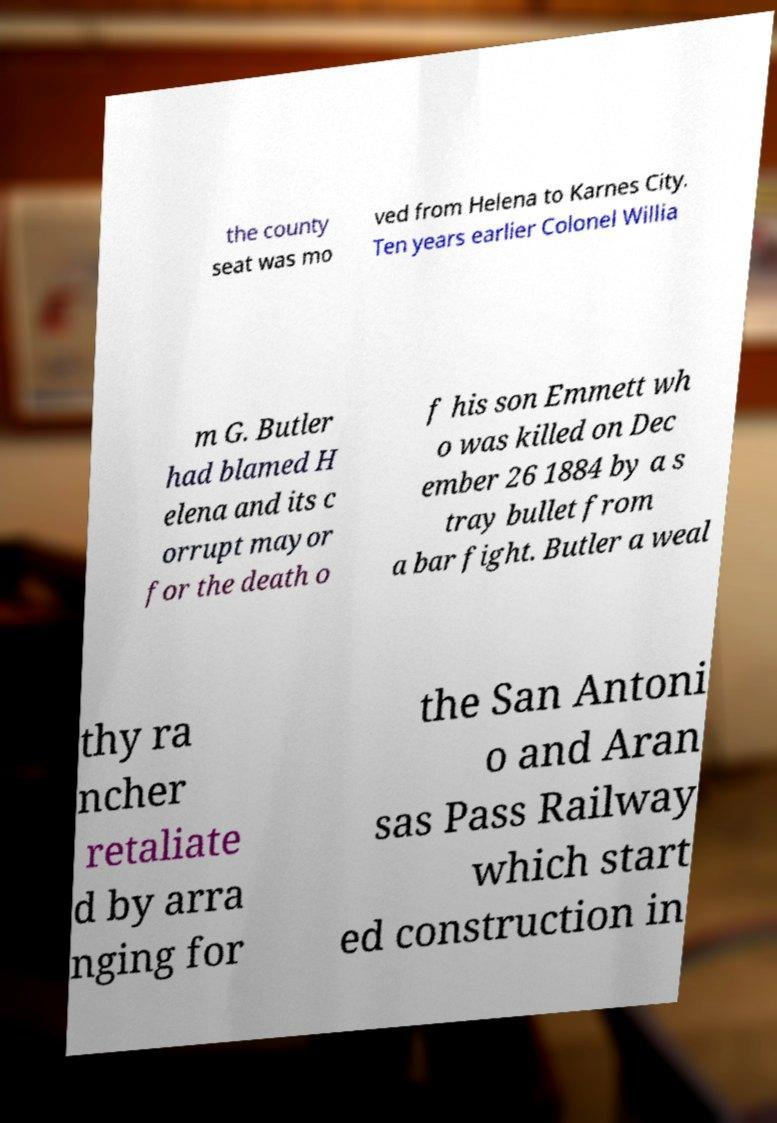For documentation purposes, I need the text within this image transcribed. Could you provide that? the county seat was mo ved from Helena to Karnes City. Ten years earlier Colonel Willia m G. Butler had blamed H elena and its c orrupt mayor for the death o f his son Emmett wh o was killed on Dec ember 26 1884 by a s tray bullet from a bar fight. Butler a weal thy ra ncher retaliate d by arra nging for the San Antoni o and Aran sas Pass Railway which start ed construction in 